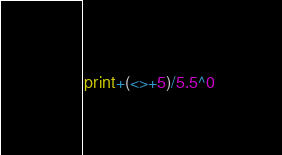Convert code to text. <code><loc_0><loc_0><loc_500><loc_500><_Perl_>print+(<>+5)/5.5^0</code> 